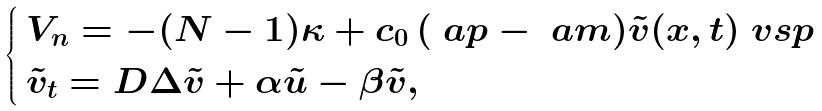Convert formula to latex. <formula><loc_0><loc_0><loc_500><loc_500>\begin{cases} \, V _ { n } = - ( N - 1 ) \kappa + c _ { 0 } \, ( \ a p - \ a m ) \tilde { v } ( x , t ) \ v s p \\ \, \tilde { v } _ { t } = D \Delta \tilde { v } + \alpha \tilde { u } - \beta \tilde { v } , \end{cases}</formula> 